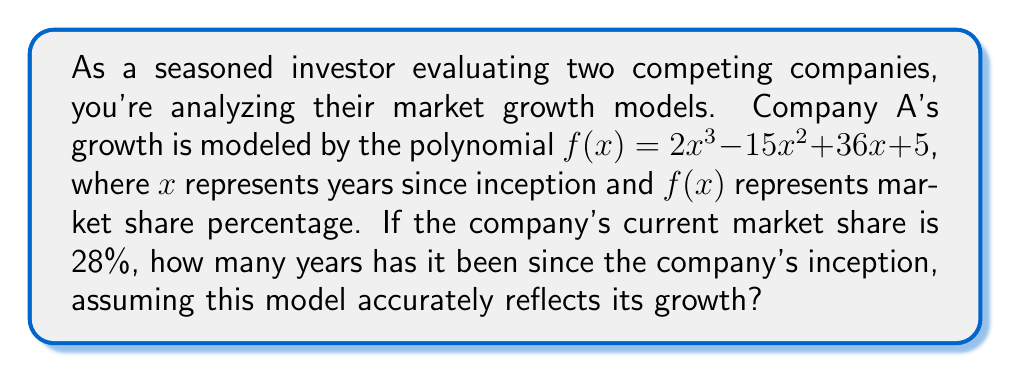Can you solve this math problem? To solve this problem, we need to find the value of x (years since inception) when f(x) = 28 (current market share percentage). Let's approach this step-by-step:

1) Set up the equation:
   $2x^3 - 15x^2 + 36x + 5 = 28$

2) Rearrange the equation to standard form:
   $2x^3 - 15x^2 + 36x - 23 = 0$

3) This is a cubic equation. While there are methods to solve cubics analytically, they're complex. In practice, we often use numerical methods or graphing calculators. However, we can deduce that the solution is likely an integer, given the context.

4) Let's try some integer values:

   For x = 1: $2(1)^3 - 15(1)^2 + 36(1) - 23 = 2 - 15 + 36 - 23 = 0$

5) We've found our solution: x = 1 satisfies the equation.

6) To verify:
   $f(1) = 2(1)^3 - 15(1)^2 + 36(1) + 5$
         $= 2 - 15 + 36 + 5$
         $= 28$

Therefore, it has been 1 year since the company's inception.
Answer: 1 year 